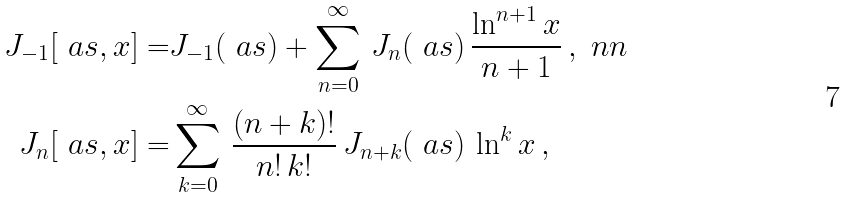<formula> <loc_0><loc_0><loc_500><loc_500>J _ { - 1 } [ \ a s , x ] = & J _ { - 1 } ( \ a s ) + \sum _ { n = 0 } ^ { \infty } \, J _ { n } ( \ a s ) \, \frac { \ln ^ { n + 1 } x } { n + 1 } \, , \ n n \\ J _ { n } [ \ a s , x ] = & \sum _ { k = 0 } ^ { \infty } \, \frac { ( n + k ) ! } { n ! \, k ! } \, J _ { n + k } ( \ a s ) \, \ln ^ { k } x \, ,</formula> 